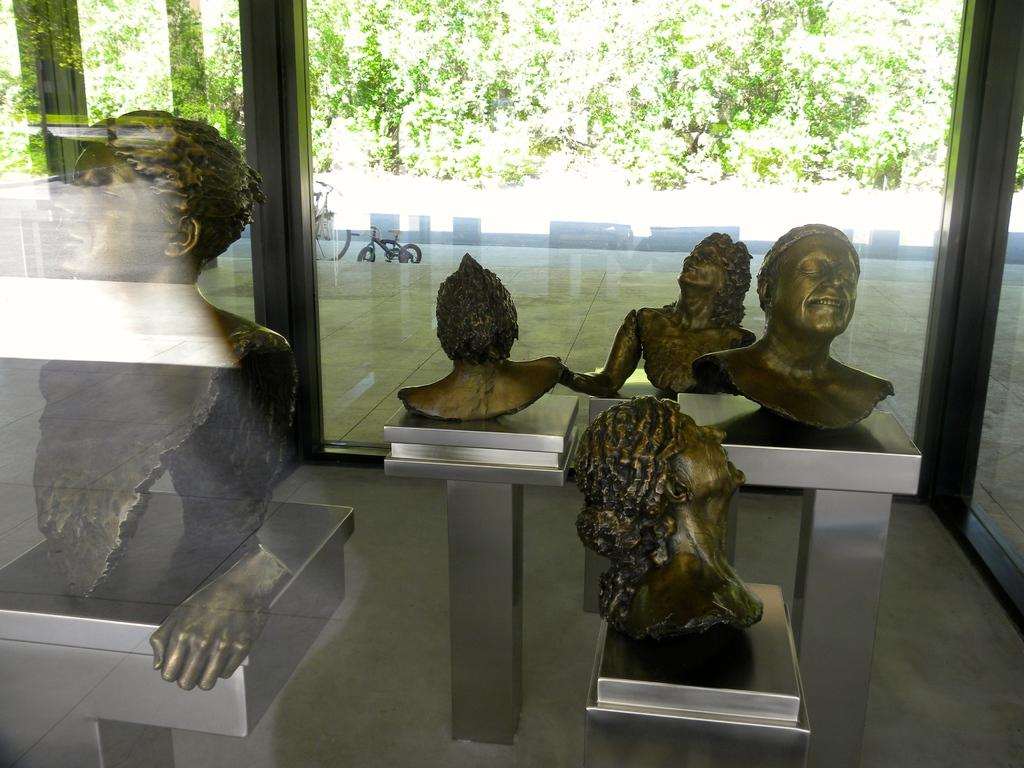What is being displayed in the glass enclosure in the image? There are artifacts showcased in a glass enclosure, depicting humans. What can be seen in the background of the image? There are two bicycles and trees in the background. What type of cable is being used to support the trees in the image? There is no cable visible in the image; the trees are standing on their own. 